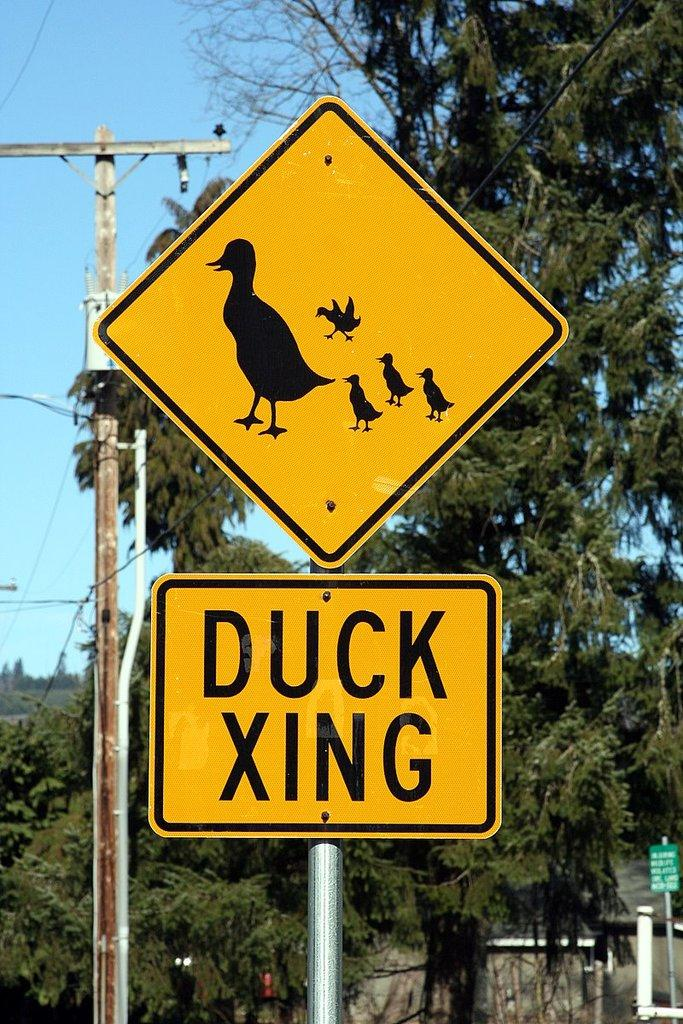<image>
Share a concise interpretation of the image provided. a Duck XING sign with a sign showing a mother duck and her ducklings behind her 